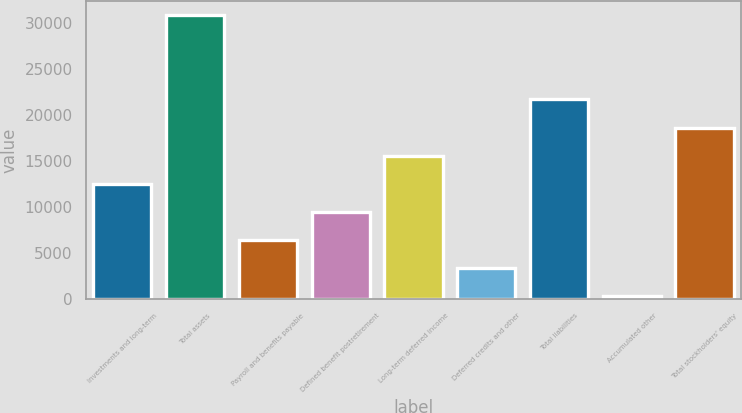Convert chart to OTSL. <chart><loc_0><loc_0><loc_500><loc_500><bar_chart><fcel>Investments and long-term<fcel>Total assets<fcel>Payroll and benefits payable<fcel>Defined benefit postretirement<fcel>Long-term deferred income<fcel>Deferred credits and other<fcel>Total liabilities<fcel>Accumulated other<fcel>Total stockholders' equity<nl><fcel>12553.2<fcel>30831<fcel>6460.6<fcel>9506.9<fcel>15599.5<fcel>3414.3<fcel>21692.1<fcel>368<fcel>18645.8<nl></chart> 